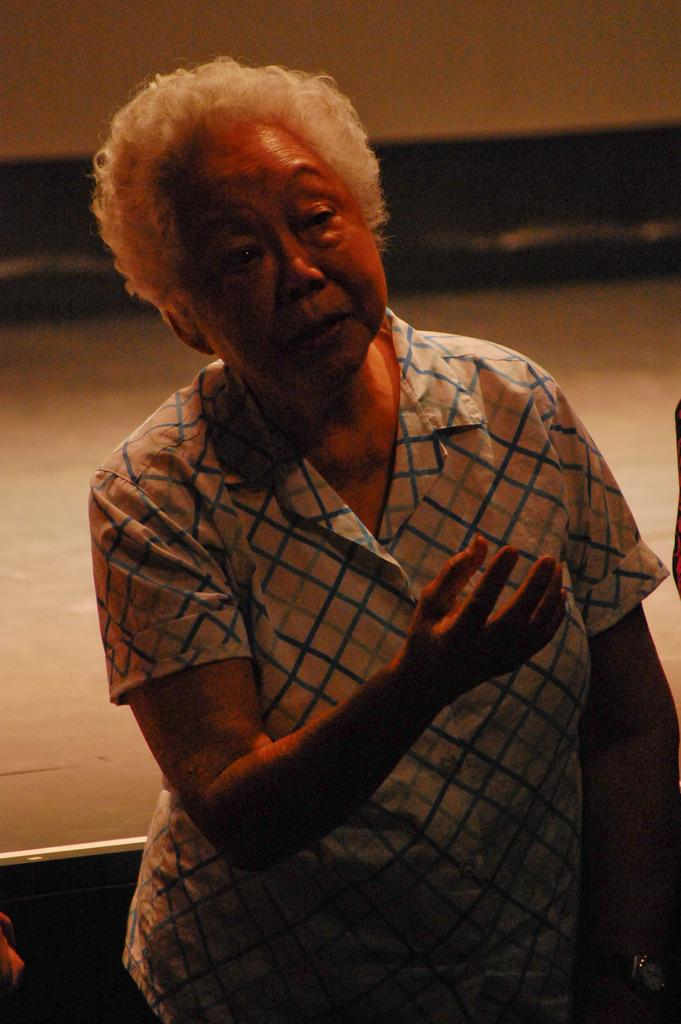What is the main subject of the image? There is a person standing in the image. What is the person wearing? The person is wearing a white and blue color dress. Can you describe the background of the image? The background of the image is in white and black color. Is there a pipe visible in the image? No, there is no pipe present in the image. What type of love is being expressed in the image? There is no indication of love being expressed in the image, as it only features a person standing in a white and blue dress against a white and black background. 